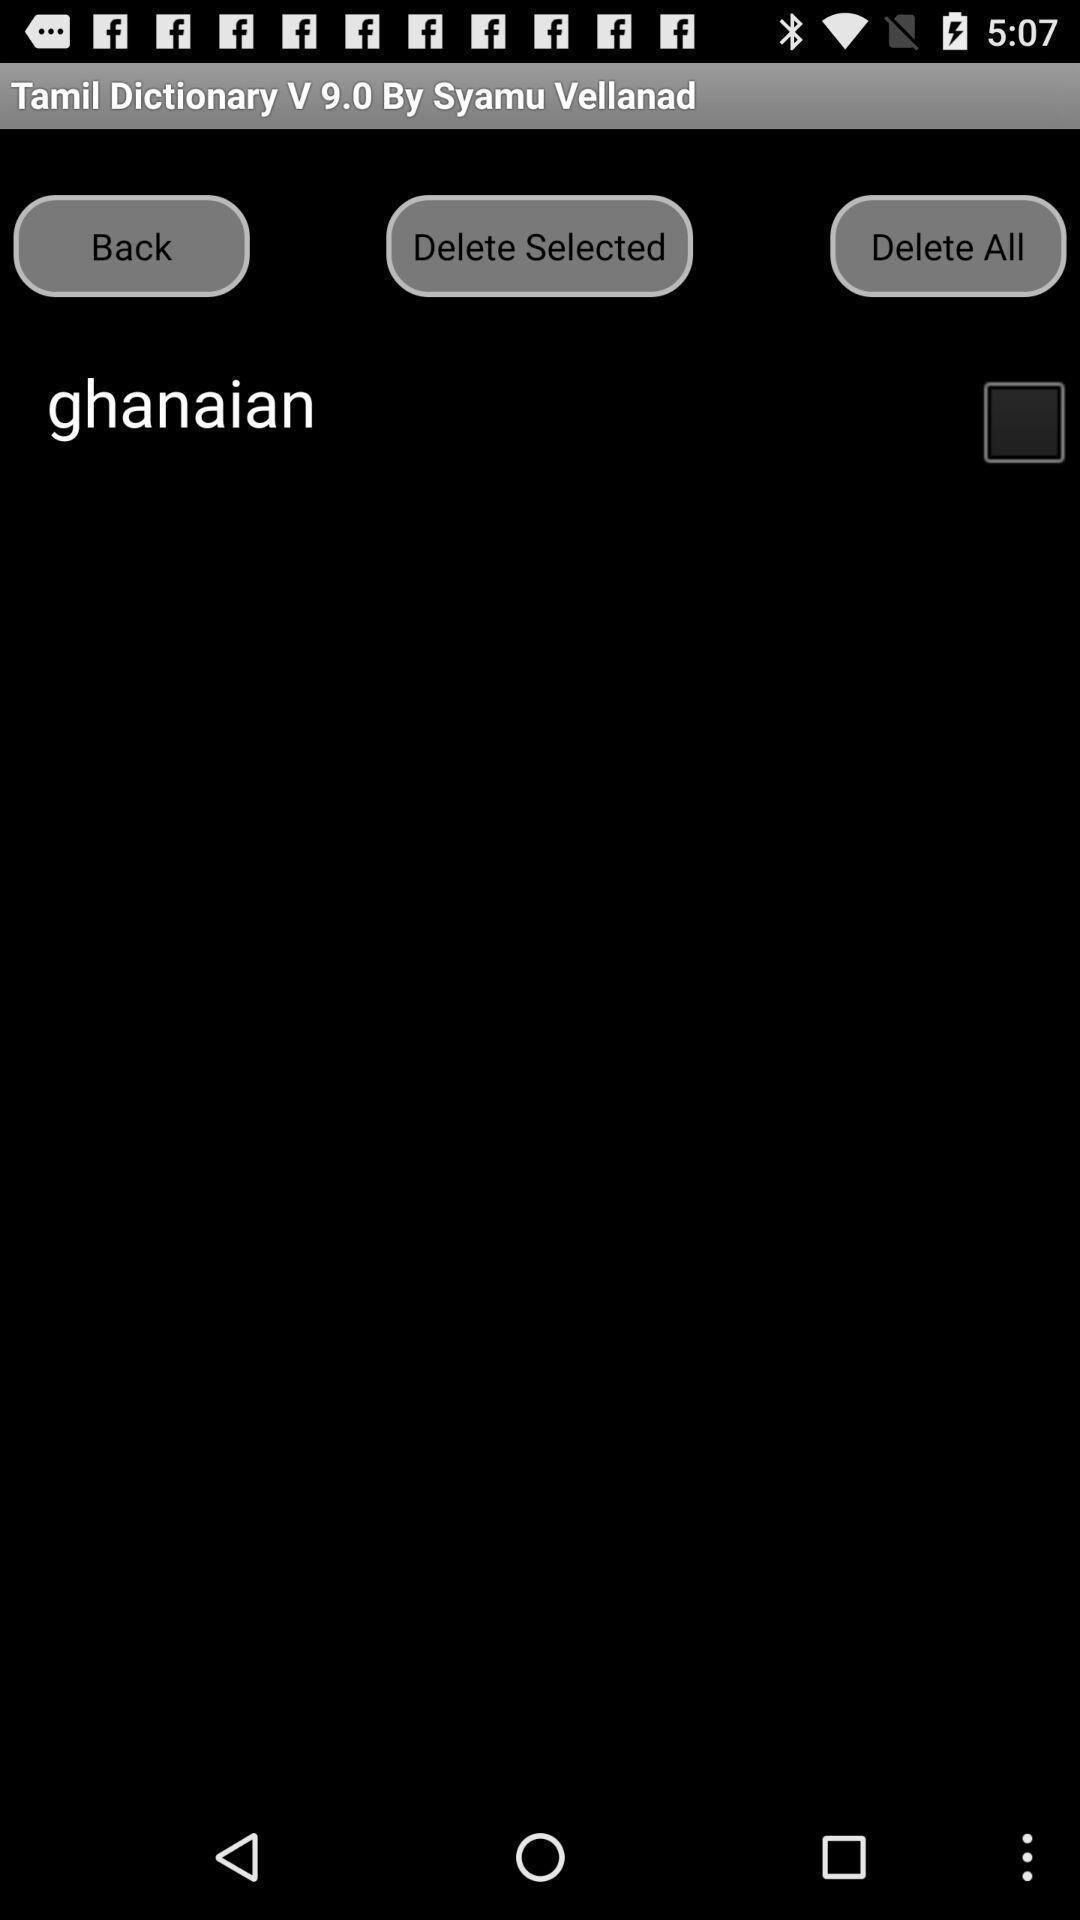Describe the content in this image. Screen shows a page about other language dictionary. 